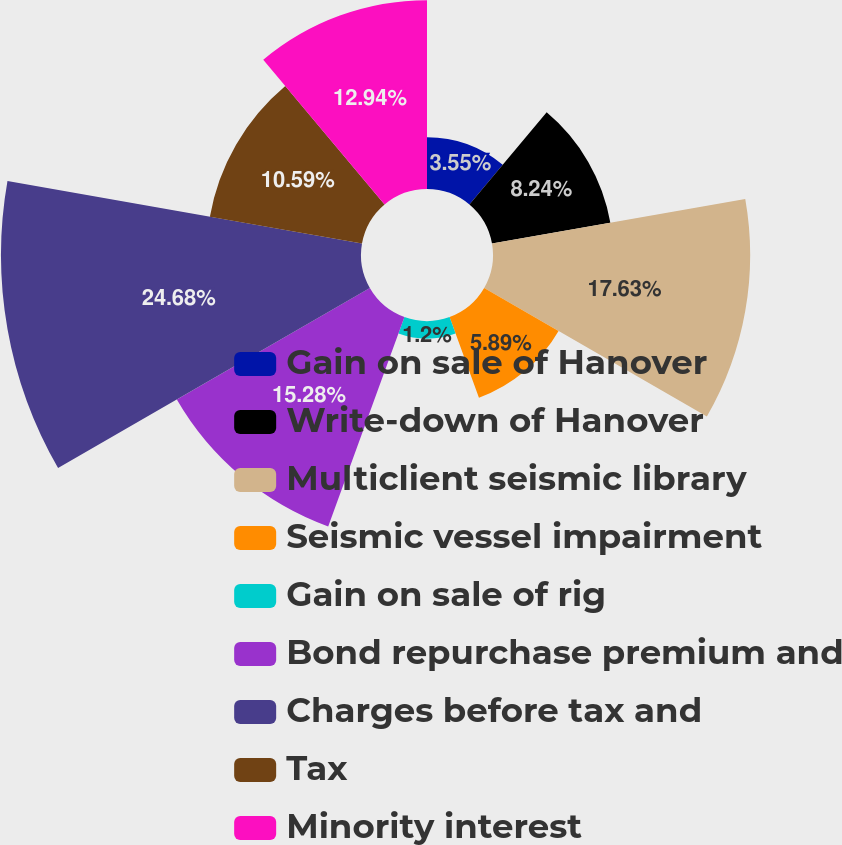<chart> <loc_0><loc_0><loc_500><loc_500><pie_chart><fcel>Gain on sale of Hanover<fcel>Write-down of Hanover<fcel>Multiclient seismic library<fcel>Seismic vessel impairment<fcel>Gain on sale of rig<fcel>Bond repurchase premium and<fcel>Charges before tax and<fcel>Tax<fcel>Minority interest<nl><fcel>3.55%<fcel>8.24%<fcel>17.63%<fcel>5.89%<fcel>1.2%<fcel>15.28%<fcel>24.68%<fcel>10.59%<fcel>12.94%<nl></chart> 